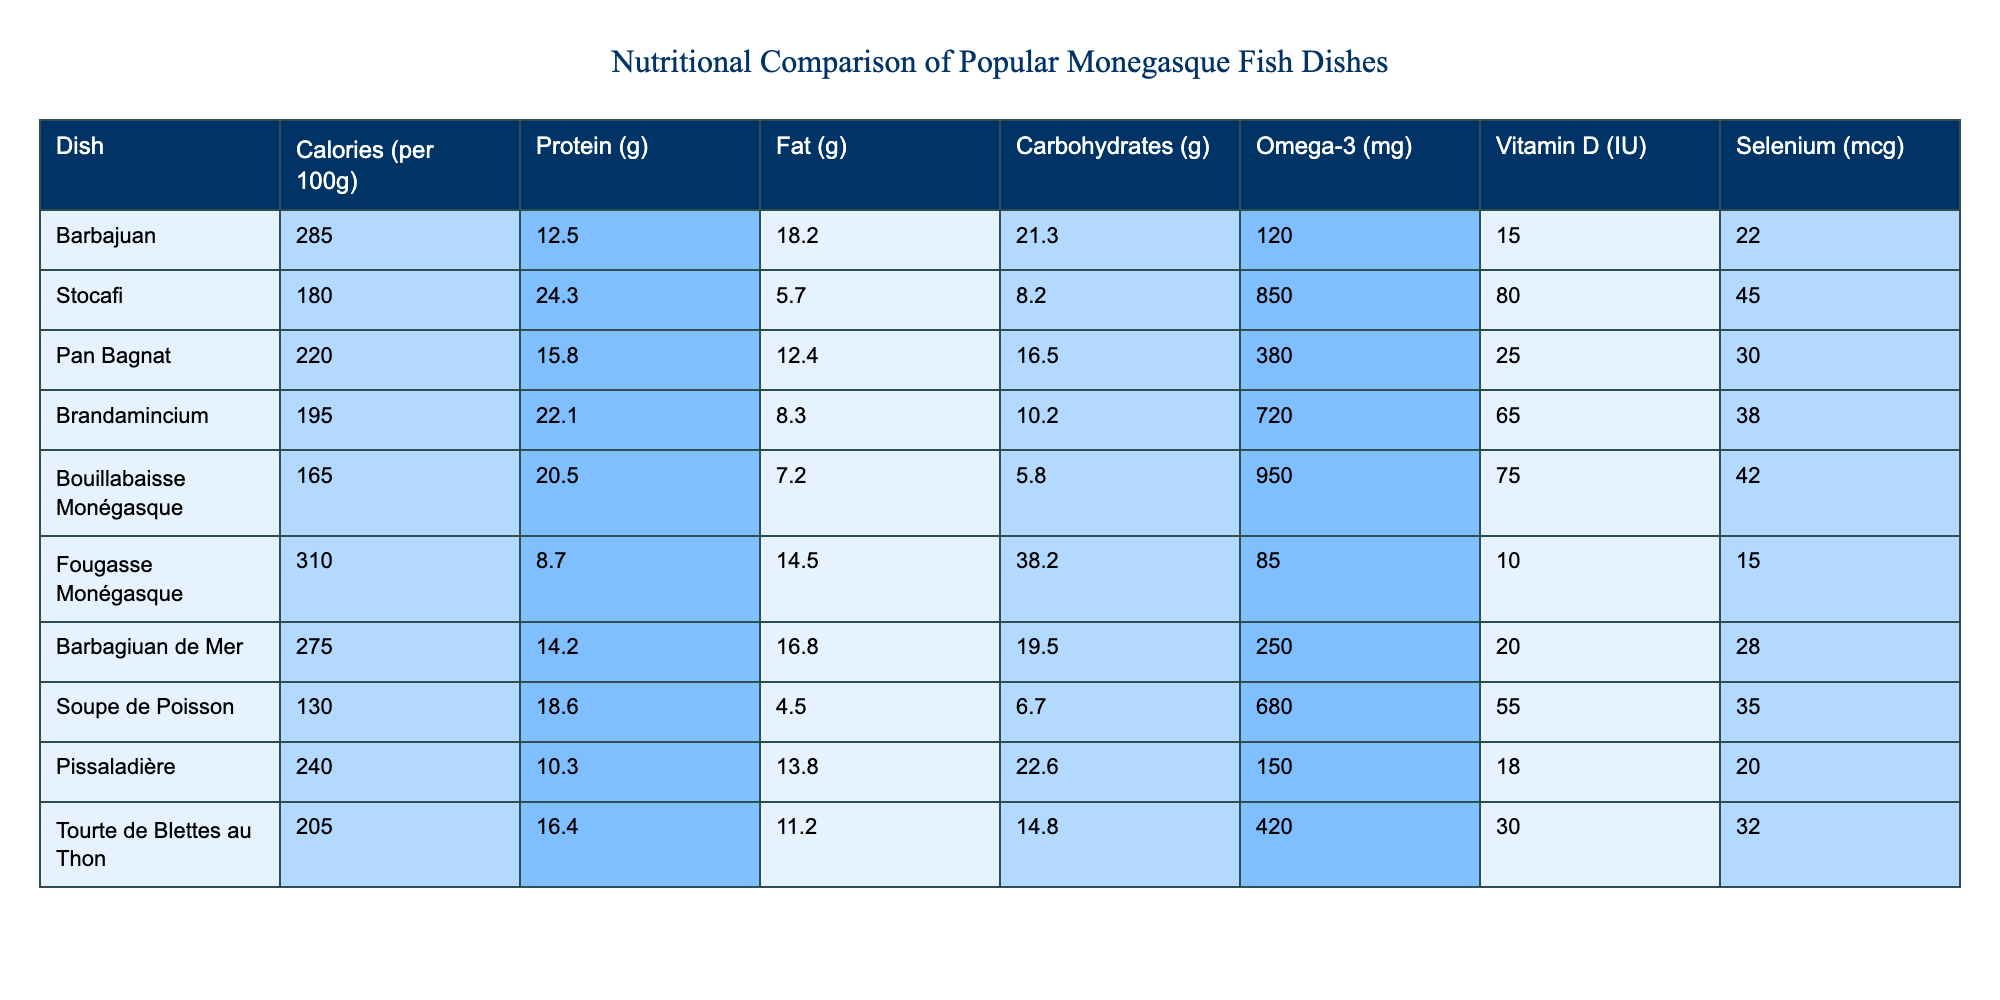What dish has the highest protein content? Looking at the "Protein" column, "Stocafi" has the highest protein content at 24.3 grams per 100 grams.
Answer: Stocafi What is the difference in calories between Barbajuan and Bouillabaisse Monégasque? Barbajuan has 285 calories, while Bouillabaisse Monégasque has 165 calories. The difference is 285 - 165 = 120 calories.
Answer: 120 calories Which dish has the lowest amount of fat? From the "Fat" column, "Soupe de Poisson" has the lowest fat content at 4.5 grams per 100 grams.
Answer: Soupe de Poisson What is the average Omega-3 content of the dishes listed? To find the average, sum the Omega-3 values (120 + 850 + 380 + 720 + 950 + 85 + 250 + 680 + 150 + 420) = 3,735. There are 10 dishes, so the average is 3735 / 10 = 373.5 mg.
Answer: 373.5 mg Is there a dish that contains more than 30 mcg of Selenium? Yes, "Stocafi," "Brandamincium," "Bouillabaisse Monégasque," and "Tourte de Blettes au Thon" all contain more than 30 mcg of Selenium.
Answer: Yes Which dish has the highest Vitamin D content, and what is its value? Referring to the "Vitamin D" column, "Stocafi" has the highest Vitamin D content at 80 IU.
Answer: 80 IU What is the total carbohydrate content of Barbagiuan de Mer and Pan Bagnat? Barbagiuan de Mer has 19.5 grams and Pan Bagnat has 16.5 grams in carbohydrates. The total is 19.5 + 16.5 = 36 grams.
Answer: 36 grams Which dish contains the least Omega-3? The "Fougasse Monégasque" has the least Omega-3 content at 85 mg per 100 grams.
Answer: Fougasse Monégasque Does any dish have more than 300 calories? Yes, "Fougasse Monégasque" has 310 calories, which is more than 300.
Answer: Yes What is the relationship between high fat content and calorie count for the dishes listed? Dishes with higher fat content generally have higher calorie counts; for example, "Fougasse Monégasque" with 14.5 g fat has 310 calories, while "Bouillabaisse Monégasque" with 7.2 g fat has fewer calories at 165.
Answer: Higher fat content corresponds with higher calories 